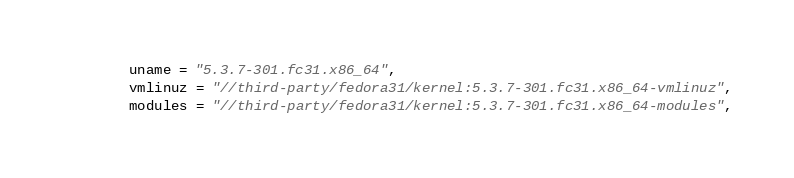Convert code to text. <code><loc_0><loc_0><loc_500><loc_500><_Python_>        uname = "5.3.7-301.fc31.x86_64",
        vmlinuz = "//third-party/fedora31/kernel:5.3.7-301.fc31.x86_64-vmlinuz",
        modules = "//third-party/fedora31/kernel:5.3.7-301.fc31.x86_64-modules",</code> 